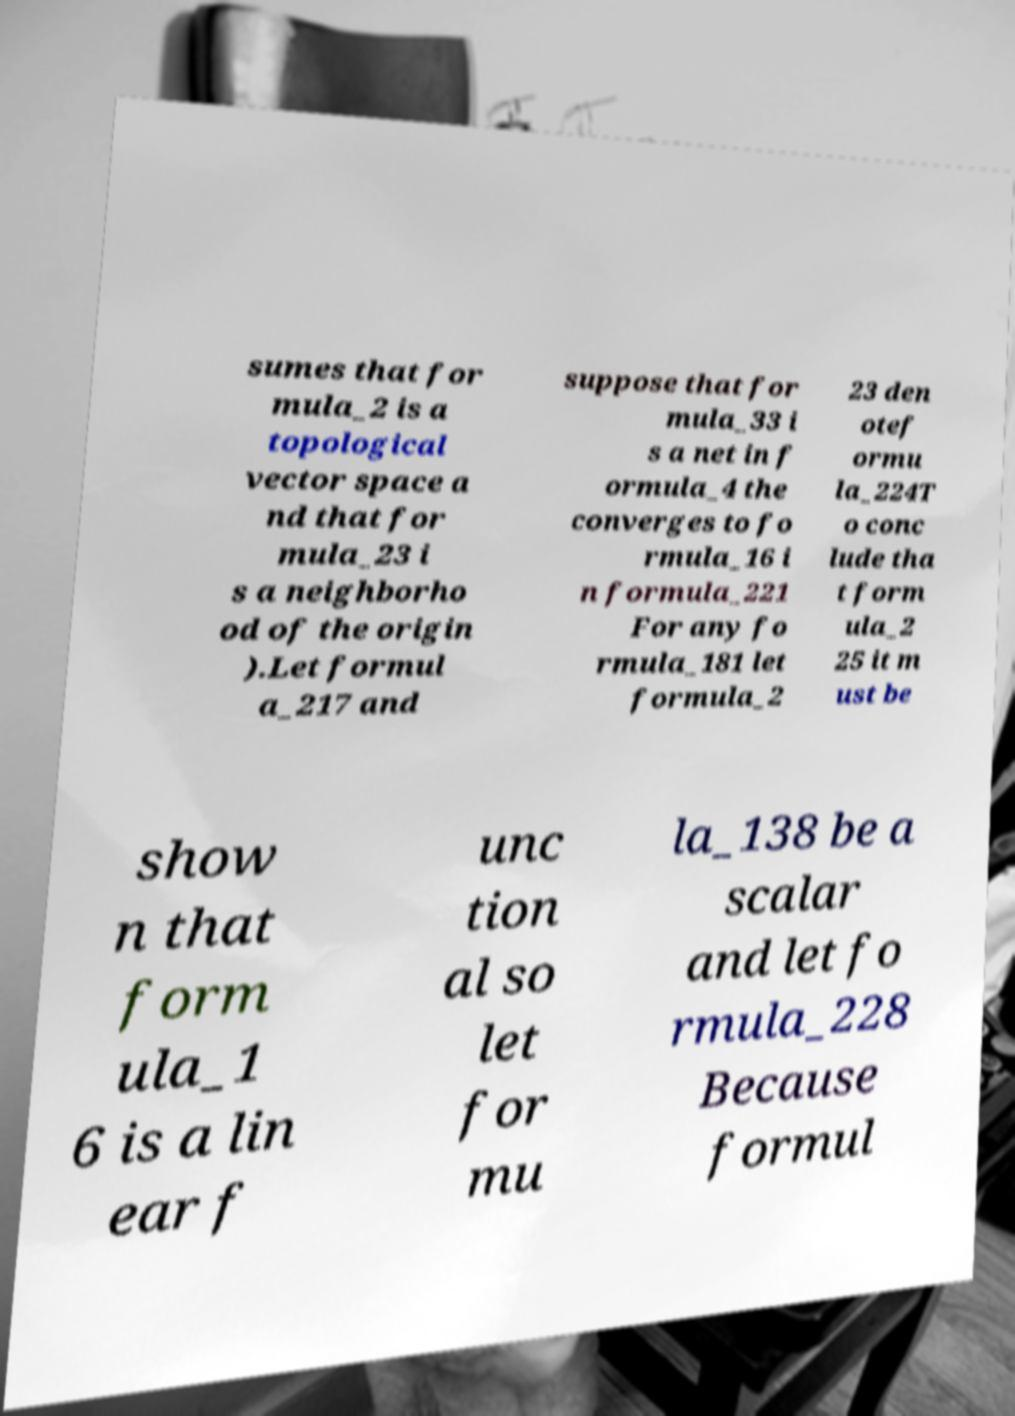Could you assist in decoding the text presented in this image and type it out clearly? sumes that for mula_2 is a topological vector space a nd that for mula_23 i s a neighborho od of the origin ).Let formul a_217 and suppose that for mula_33 i s a net in f ormula_4 the converges to fo rmula_16 i n formula_221 For any fo rmula_181 let formula_2 23 den otef ormu la_224T o conc lude tha t form ula_2 25 it m ust be show n that form ula_1 6 is a lin ear f unc tion al so let for mu la_138 be a scalar and let fo rmula_228 Because formul 